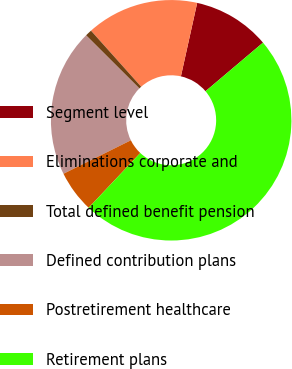Convert chart to OTSL. <chart><loc_0><loc_0><loc_500><loc_500><pie_chart><fcel>Segment level<fcel>Eliminations corporate and<fcel>Total defined benefit pension<fcel>Defined contribution plans<fcel>Postretirement healthcare<fcel>Retirement plans<nl><fcel>10.36%<fcel>15.09%<fcel>0.9%<fcel>19.82%<fcel>5.63%<fcel>48.2%<nl></chart> 